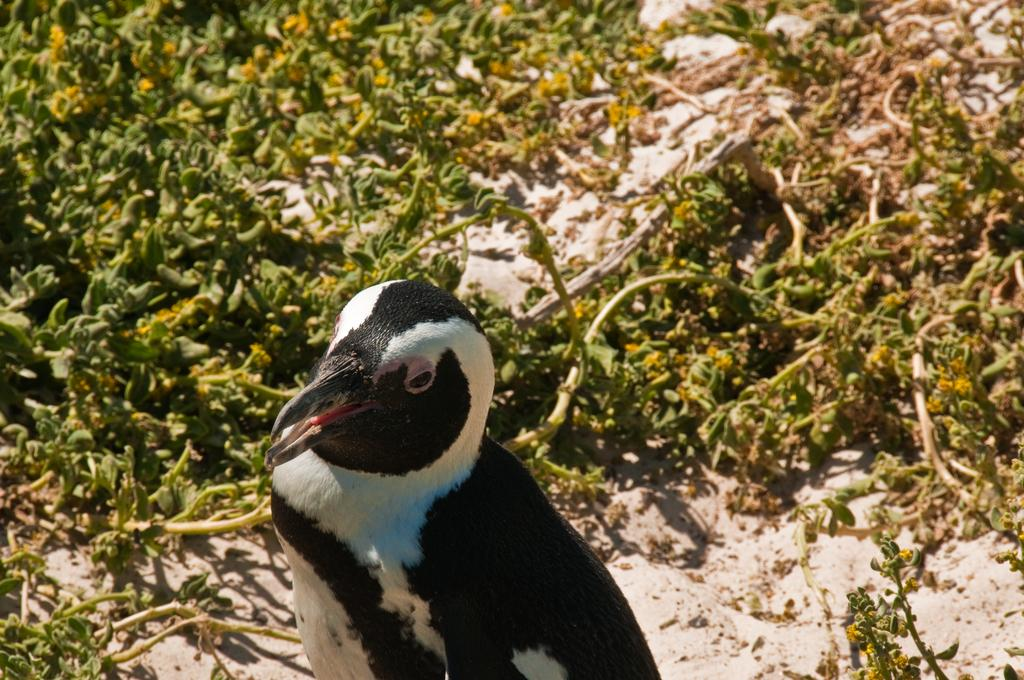What type of animal is in the image? There is a penguin in the image. What can be seen in the background of the image? There are plants visible in the background of the image. How many clocks are hanging on the rail in the image? There are no clocks or rails present in the image; it features a penguin and plants in the background. What type of wealth is depicted in the image? There is no depiction of wealth in the image; it features a penguin and plants in the background. 